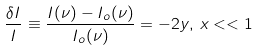<formula> <loc_0><loc_0><loc_500><loc_500>\frac { \delta I } I \equiv \frac { I ( \nu ) - I _ { o } ( \nu ) } { I _ { o } ( \nu ) } = - 2 y , \, x < < 1</formula> 